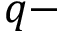<formula> <loc_0><loc_0><loc_500><loc_500>q -</formula> 